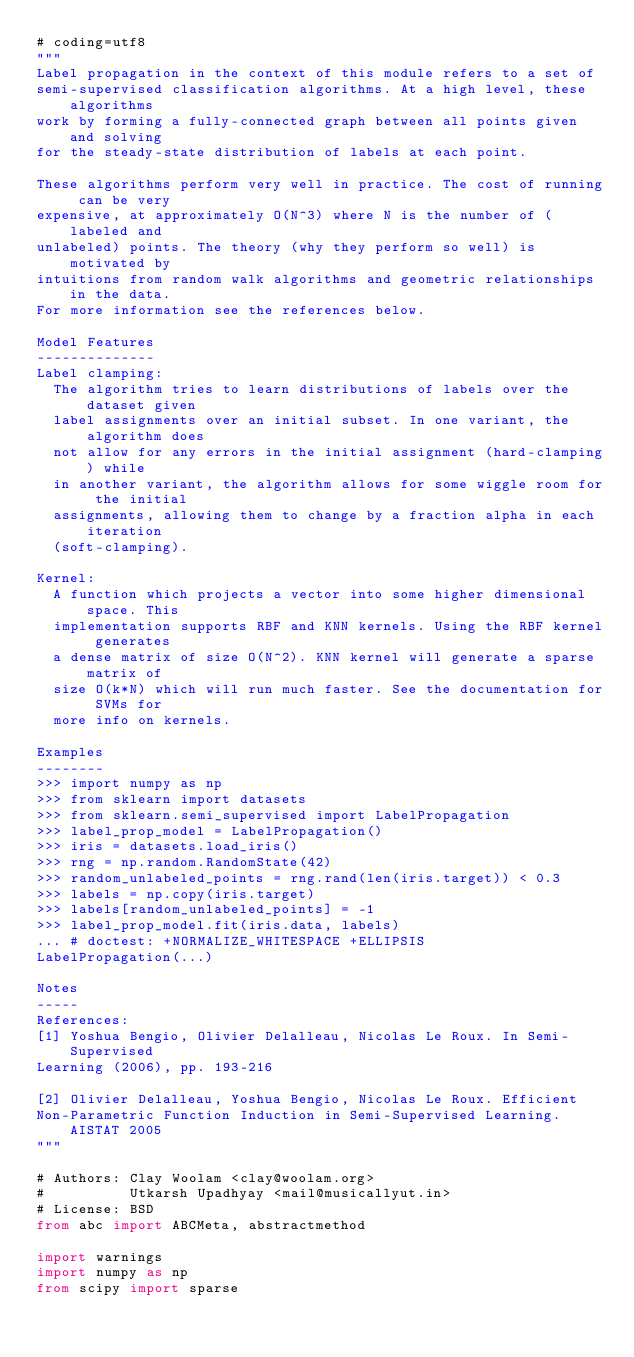Convert code to text. <code><loc_0><loc_0><loc_500><loc_500><_Python_># coding=utf8
"""
Label propagation in the context of this module refers to a set of
semi-supervised classification algorithms. At a high level, these algorithms
work by forming a fully-connected graph between all points given and solving
for the steady-state distribution of labels at each point.

These algorithms perform very well in practice. The cost of running can be very
expensive, at approximately O(N^3) where N is the number of (labeled and
unlabeled) points. The theory (why they perform so well) is motivated by
intuitions from random walk algorithms and geometric relationships in the data.
For more information see the references below.

Model Features
--------------
Label clamping:
  The algorithm tries to learn distributions of labels over the dataset given
  label assignments over an initial subset. In one variant, the algorithm does
  not allow for any errors in the initial assignment (hard-clamping) while
  in another variant, the algorithm allows for some wiggle room for the initial
  assignments, allowing them to change by a fraction alpha in each iteration
  (soft-clamping).

Kernel:
  A function which projects a vector into some higher dimensional space. This
  implementation supports RBF and KNN kernels. Using the RBF kernel generates
  a dense matrix of size O(N^2). KNN kernel will generate a sparse matrix of
  size O(k*N) which will run much faster. See the documentation for SVMs for
  more info on kernels.

Examples
--------
>>> import numpy as np
>>> from sklearn import datasets
>>> from sklearn.semi_supervised import LabelPropagation
>>> label_prop_model = LabelPropagation()
>>> iris = datasets.load_iris()
>>> rng = np.random.RandomState(42)
>>> random_unlabeled_points = rng.rand(len(iris.target)) < 0.3
>>> labels = np.copy(iris.target)
>>> labels[random_unlabeled_points] = -1
>>> label_prop_model.fit(iris.data, labels)
... # doctest: +NORMALIZE_WHITESPACE +ELLIPSIS
LabelPropagation(...)

Notes
-----
References:
[1] Yoshua Bengio, Olivier Delalleau, Nicolas Le Roux. In Semi-Supervised
Learning (2006), pp. 193-216

[2] Olivier Delalleau, Yoshua Bengio, Nicolas Le Roux. Efficient
Non-Parametric Function Induction in Semi-Supervised Learning. AISTAT 2005
"""

# Authors: Clay Woolam <clay@woolam.org>
#          Utkarsh Upadhyay <mail@musicallyut.in>
# License: BSD
from abc import ABCMeta, abstractmethod

import warnings
import numpy as np
from scipy import sparse</code> 